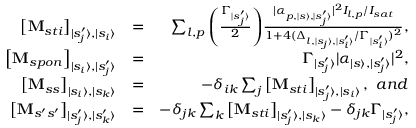<formula> <loc_0><loc_0><loc_500><loc_500>\begin{array} { r l r } { \left [ M _ { s t i } \right ] _ { | s _ { j } ^ { \prime } \rangle , | s _ { i } \rangle } } & { = } & { \sum _ { l , p } \left ( { \frac { \Gamma _ { | s _ { j } ^ { \prime } \rangle } } { 2 } } \right ) \, { \frac { | \alpha _ { p , | s \rangle , | s _ { j } ^ { \prime } \rangle } | ^ { 2 } I _ { l , p } / I _ { s a t } } { 1 + 4 ( \Delta _ { l , | s _ { j } \rangle , | s _ { i } ^ { \prime } \rangle } / \Gamma _ { | s _ { i } ^ { \prime } \rangle } ) ^ { 2 } } } , } \\ { \left [ M _ { s p o n } \right ] _ { | s _ { i } \rangle , | s _ { j } ^ { \prime } \rangle } } & { = } & { \Gamma _ { | s _ { j } ^ { \prime } \rangle } | \alpha _ { | s \rangle , | s _ { j } ^ { \prime } \rangle } | ^ { 2 } , } \\ { \left [ M _ { s s } \right ] _ { | s _ { i } \rangle , | s _ { k } \rangle } } & { = } & { - \delta _ { i k } \sum _ { j } \left [ M _ { s t i } \right ] _ { | s _ { j } ^ { \prime } \rangle , | s _ { i } \rangle } , \ a n d } \\ { \left [ M _ { s ^ { \prime } s ^ { \prime } } \right ] _ { | s _ { j } ^ { \prime } \rangle , | s _ { k } ^ { \prime } \rangle } } & { = } & { - \delta _ { j k } \sum _ { k } \left [ M _ { s t i } \right ] _ { | s _ { j } ^ { \prime } \rangle , | s _ { k } \rangle } - \delta _ { j k } \Gamma _ { | s _ { j } ^ { \prime } \rangle } , } \end{array}</formula> 